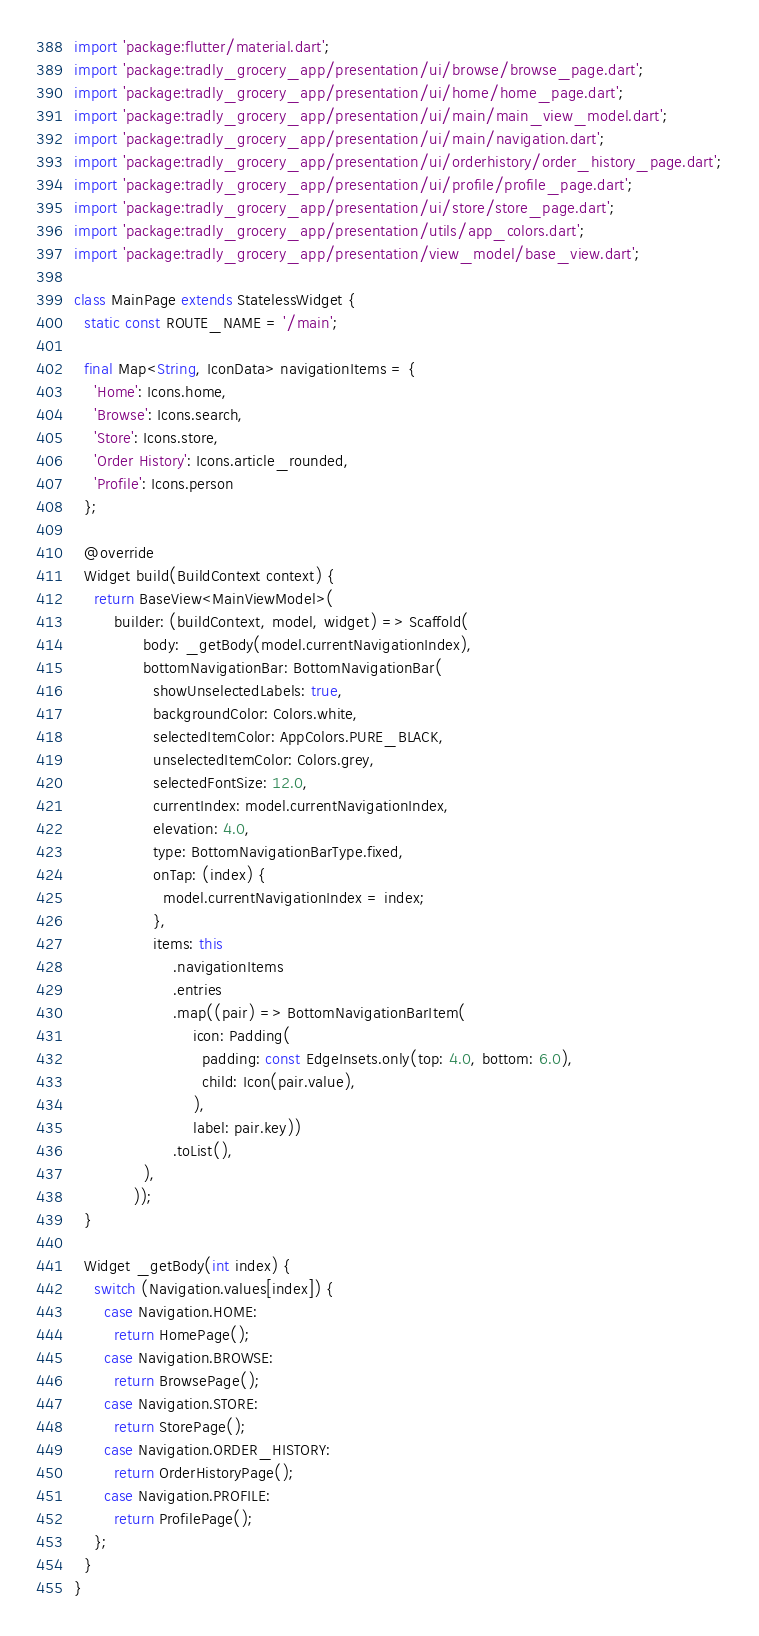Convert code to text. <code><loc_0><loc_0><loc_500><loc_500><_Dart_>import 'package:flutter/material.dart';
import 'package:tradly_grocery_app/presentation/ui/browse/browse_page.dart';
import 'package:tradly_grocery_app/presentation/ui/home/home_page.dart';
import 'package:tradly_grocery_app/presentation/ui/main/main_view_model.dart';
import 'package:tradly_grocery_app/presentation/ui/main/navigation.dart';
import 'package:tradly_grocery_app/presentation/ui/orderhistory/order_history_page.dart';
import 'package:tradly_grocery_app/presentation/ui/profile/profile_page.dart';
import 'package:tradly_grocery_app/presentation/ui/store/store_page.dart';
import 'package:tradly_grocery_app/presentation/utils/app_colors.dart';
import 'package:tradly_grocery_app/presentation/view_model/base_view.dart';

class MainPage extends StatelessWidget {
  static const ROUTE_NAME = '/main';

  final Map<String, IconData> navigationItems = {
    'Home': Icons.home,
    'Browse': Icons.search,
    'Store': Icons.store,
    'Order History': Icons.article_rounded,
    'Profile': Icons.person
  };

  @override
  Widget build(BuildContext context) {
    return BaseView<MainViewModel>(
        builder: (buildContext, model, widget) => Scaffold(
              body: _getBody(model.currentNavigationIndex),
              bottomNavigationBar: BottomNavigationBar(
                showUnselectedLabels: true,
                backgroundColor: Colors.white,
                selectedItemColor: AppColors.PURE_BLACK,
                unselectedItemColor: Colors.grey,
                selectedFontSize: 12.0,
                currentIndex: model.currentNavigationIndex,
                elevation: 4.0,
                type: BottomNavigationBarType.fixed,
                onTap: (index) {
                  model.currentNavigationIndex = index;
                },
                items: this
                    .navigationItems
                    .entries
                    .map((pair) => BottomNavigationBarItem(
                        icon: Padding(
                          padding: const EdgeInsets.only(top: 4.0, bottom: 6.0),
                          child: Icon(pair.value),
                        ),
                        label: pair.key))
                    .toList(),
              ),
            ));
  }

  Widget _getBody(int index) {
    switch (Navigation.values[index]) {
      case Navigation.HOME:
        return HomePage();
      case Navigation.BROWSE:
        return BrowsePage();
      case Navigation.STORE:
        return StorePage();
      case Navigation.ORDER_HISTORY:
        return OrderHistoryPage();
      case Navigation.PROFILE:
        return ProfilePage();
    };
  }
}
</code> 